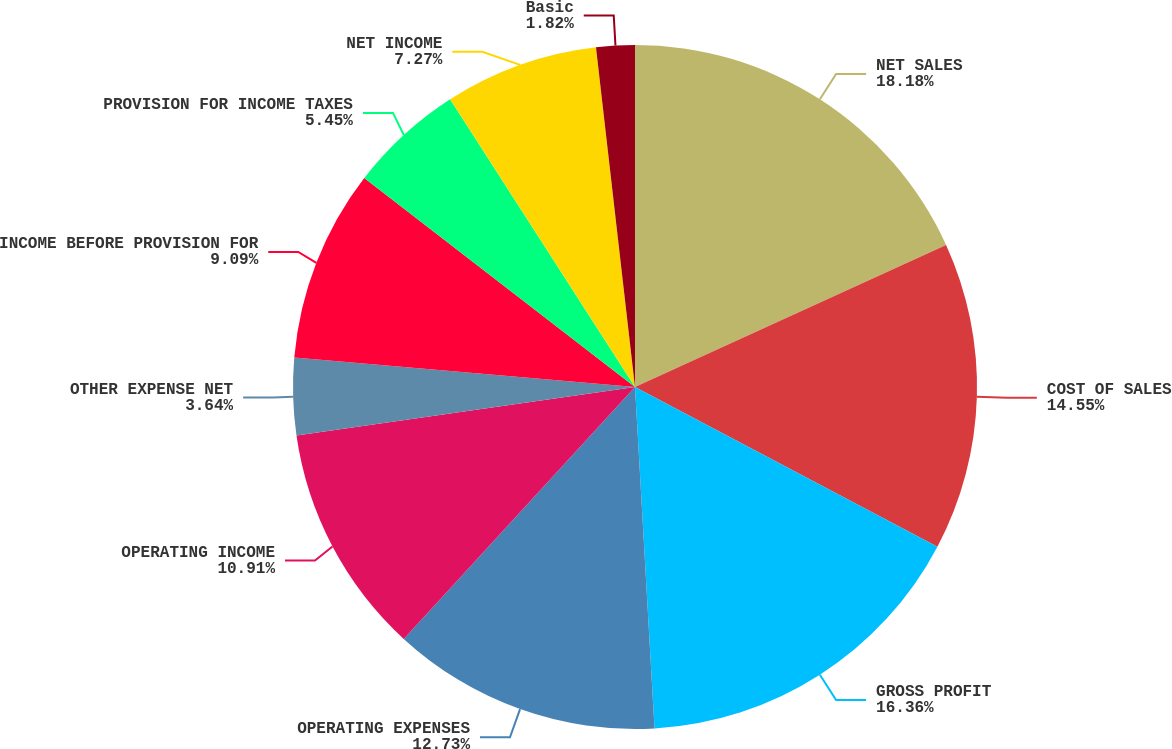<chart> <loc_0><loc_0><loc_500><loc_500><pie_chart><fcel>NET SALES<fcel>COST OF SALES<fcel>GROSS PROFIT<fcel>OPERATING EXPENSES<fcel>OPERATING INCOME<fcel>OTHER EXPENSE NET<fcel>INCOME BEFORE PROVISION FOR<fcel>PROVISION FOR INCOME TAXES<fcel>NET INCOME<fcel>Basic<nl><fcel>18.18%<fcel>14.55%<fcel>16.36%<fcel>12.73%<fcel>10.91%<fcel>3.64%<fcel>9.09%<fcel>5.45%<fcel>7.27%<fcel>1.82%<nl></chart> 